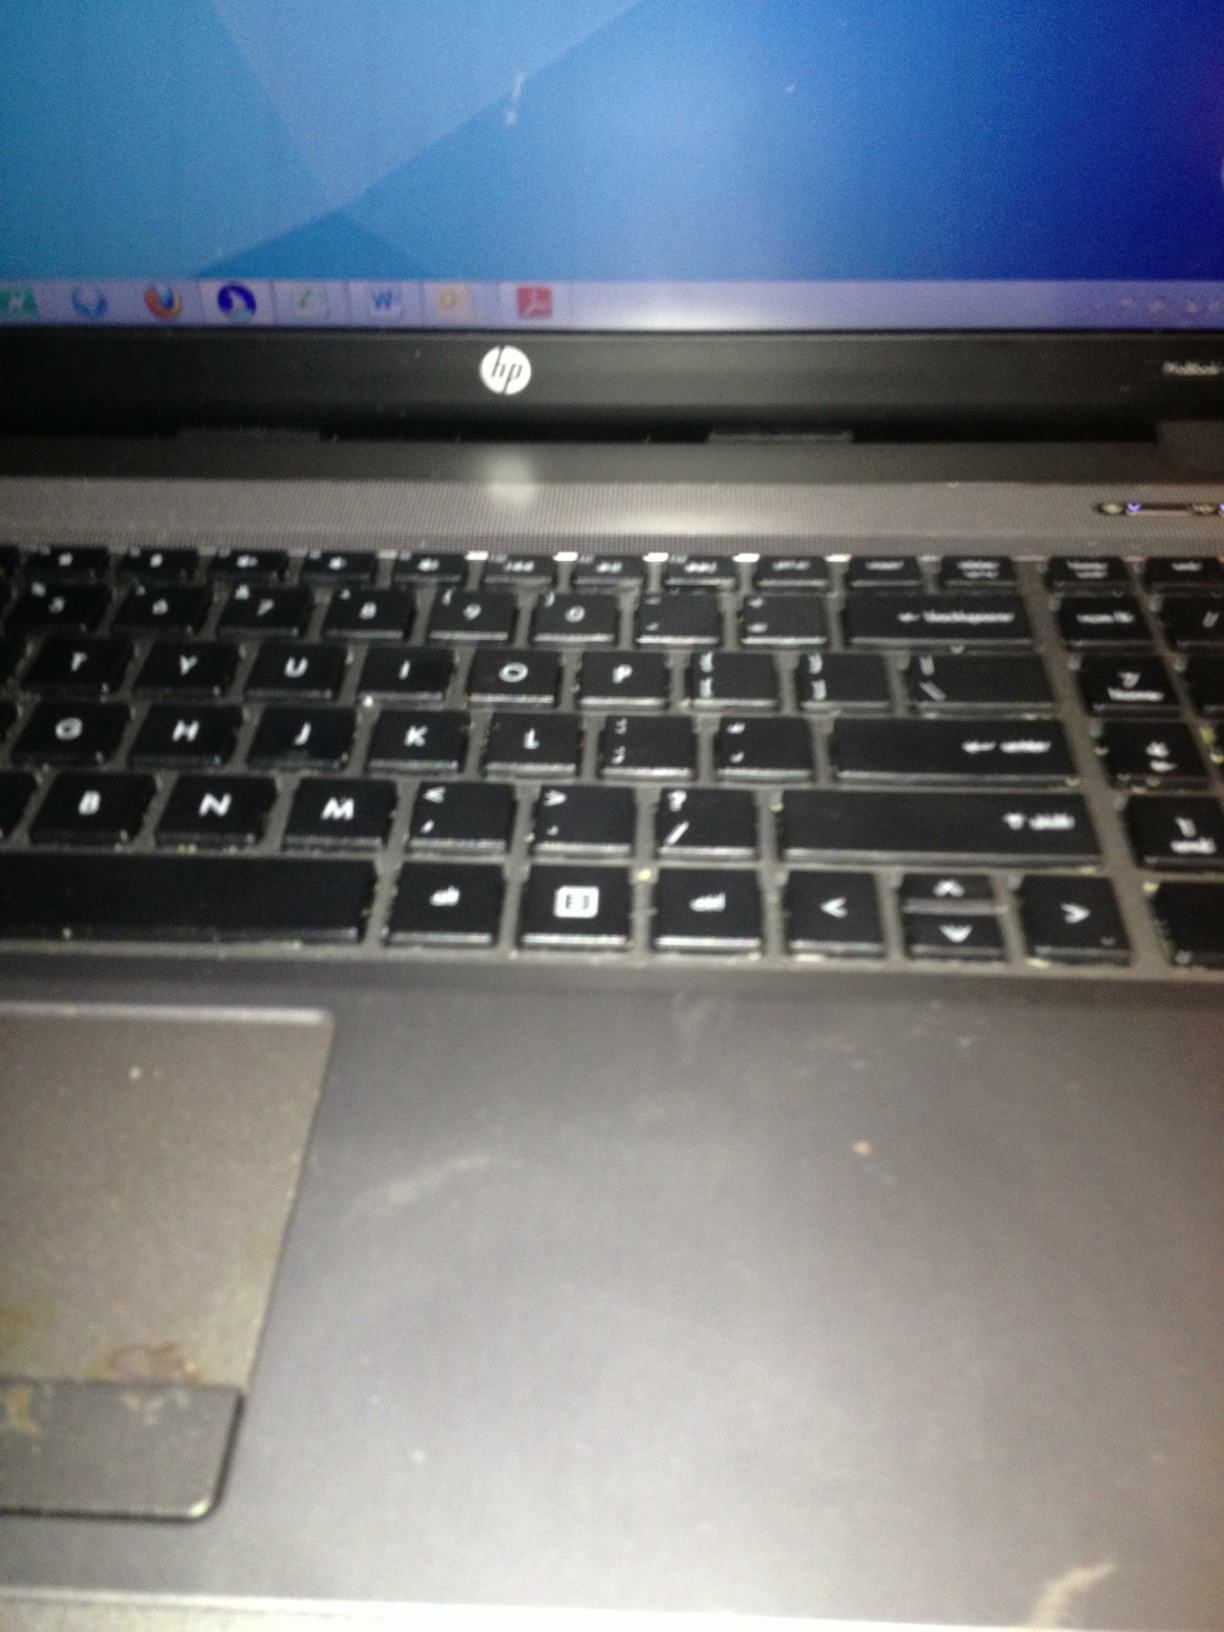Yes this is an HP laptop computer. I need to locate the card reader, I understand it's to the right of the keyboard, on the side. I need to know, is it close to the front? Close to where the key-- Yes, this is an HP laptop. Unfortunately, from this image, it isn’t clear where the card reader is located on the right side of the keyboard. Typically, card readers on HP laptops can be found on either the side near the front or closer to the back, but specific locations can vary by model. Please check the side of the laptop more closely or refer to the user manual for exact locations. 